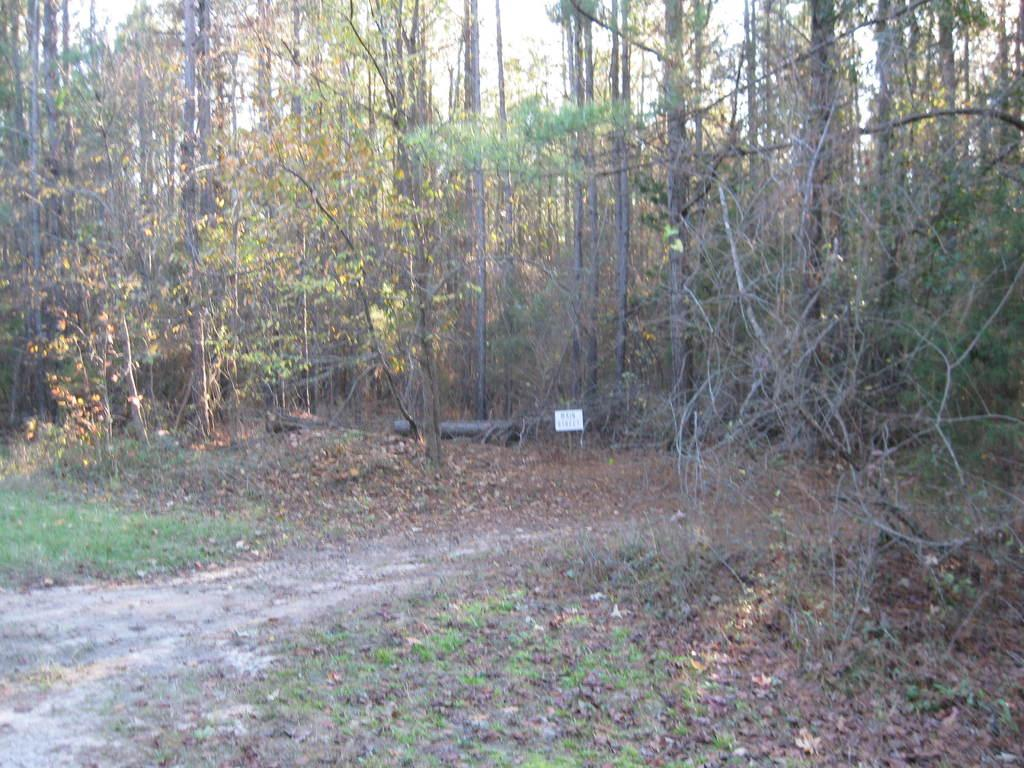What type of vegetation is present in the image? There are tall trees in the image. What is covering the ground in the image? There is grass on the ground in the image. What month is depicted in the image? The month is not depicted in the image, as it does not contain any information about a specific time or date. 